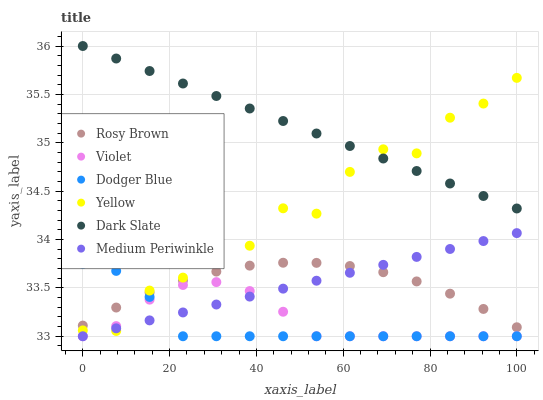Does Dodger Blue have the minimum area under the curve?
Answer yes or no. Yes. Does Dark Slate have the maximum area under the curve?
Answer yes or no. Yes. Does Medium Periwinkle have the minimum area under the curve?
Answer yes or no. No. Does Medium Periwinkle have the maximum area under the curve?
Answer yes or no. No. Is Dark Slate the smoothest?
Answer yes or no. Yes. Is Yellow the roughest?
Answer yes or no. Yes. Is Medium Periwinkle the smoothest?
Answer yes or no. No. Is Medium Periwinkle the roughest?
Answer yes or no. No. Does Medium Periwinkle have the lowest value?
Answer yes or no. Yes. Does Yellow have the lowest value?
Answer yes or no. No. Does Dark Slate have the highest value?
Answer yes or no. Yes. Does Medium Periwinkle have the highest value?
Answer yes or no. No. Is Rosy Brown less than Dark Slate?
Answer yes or no. Yes. Is Dark Slate greater than Dodger Blue?
Answer yes or no. Yes. Does Dodger Blue intersect Medium Periwinkle?
Answer yes or no. Yes. Is Dodger Blue less than Medium Periwinkle?
Answer yes or no. No. Is Dodger Blue greater than Medium Periwinkle?
Answer yes or no. No. Does Rosy Brown intersect Dark Slate?
Answer yes or no. No. 